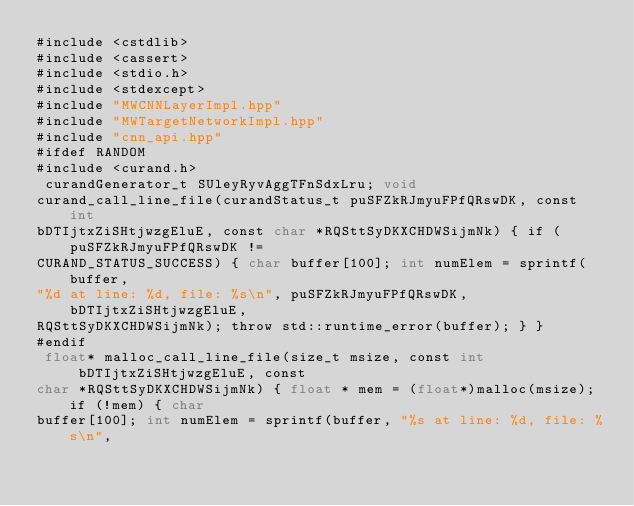Convert code to text. <code><loc_0><loc_0><loc_500><loc_500><_Cuda_>#include <cstdlib>
#include <cassert>
#include <stdio.h>
#include <stdexcept>
#include "MWCNNLayerImpl.hpp"
#include "MWTargetNetworkImpl.hpp"
#include "cnn_api.hpp"
#ifdef RANDOM
#include <curand.h>
 curandGenerator_t SUleyRyvAggTFnSdxLru; void 
curand_call_line_file(curandStatus_t puSFZkRJmyuFPfQRswDK, const int 
bDTIjtxZiSHtjwzgEluE, const char *RQSttSyDKXCHDWSijmNk) { if (puSFZkRJmyuFPfQRswDK != 
CURAND_STATUS_SUCCESS) { char buffer[100]; int numElem = sprintf(buffer, 
"%d at line: %d, file: %s\n", puSFZkRJmyuFPfQRswDK, bDTIjtxZiSHtjwzgEluE, 
RQSttSyDKXCHDWSijmNk); throw std::runtime_error(buffer); } }
#endif
 float* malloc_call_line_file(size_t msize, const int bDTIjtxZiSHtjwzgEluE, const 
char *RQSttSyDKXCHDWSijmNk) { float * mem = (float*)malloc(msize); if (!mem) { char 
buffer[100]; int numElem = sprintf(buffer, "%s at line: %d, file: %s\n", </code> 